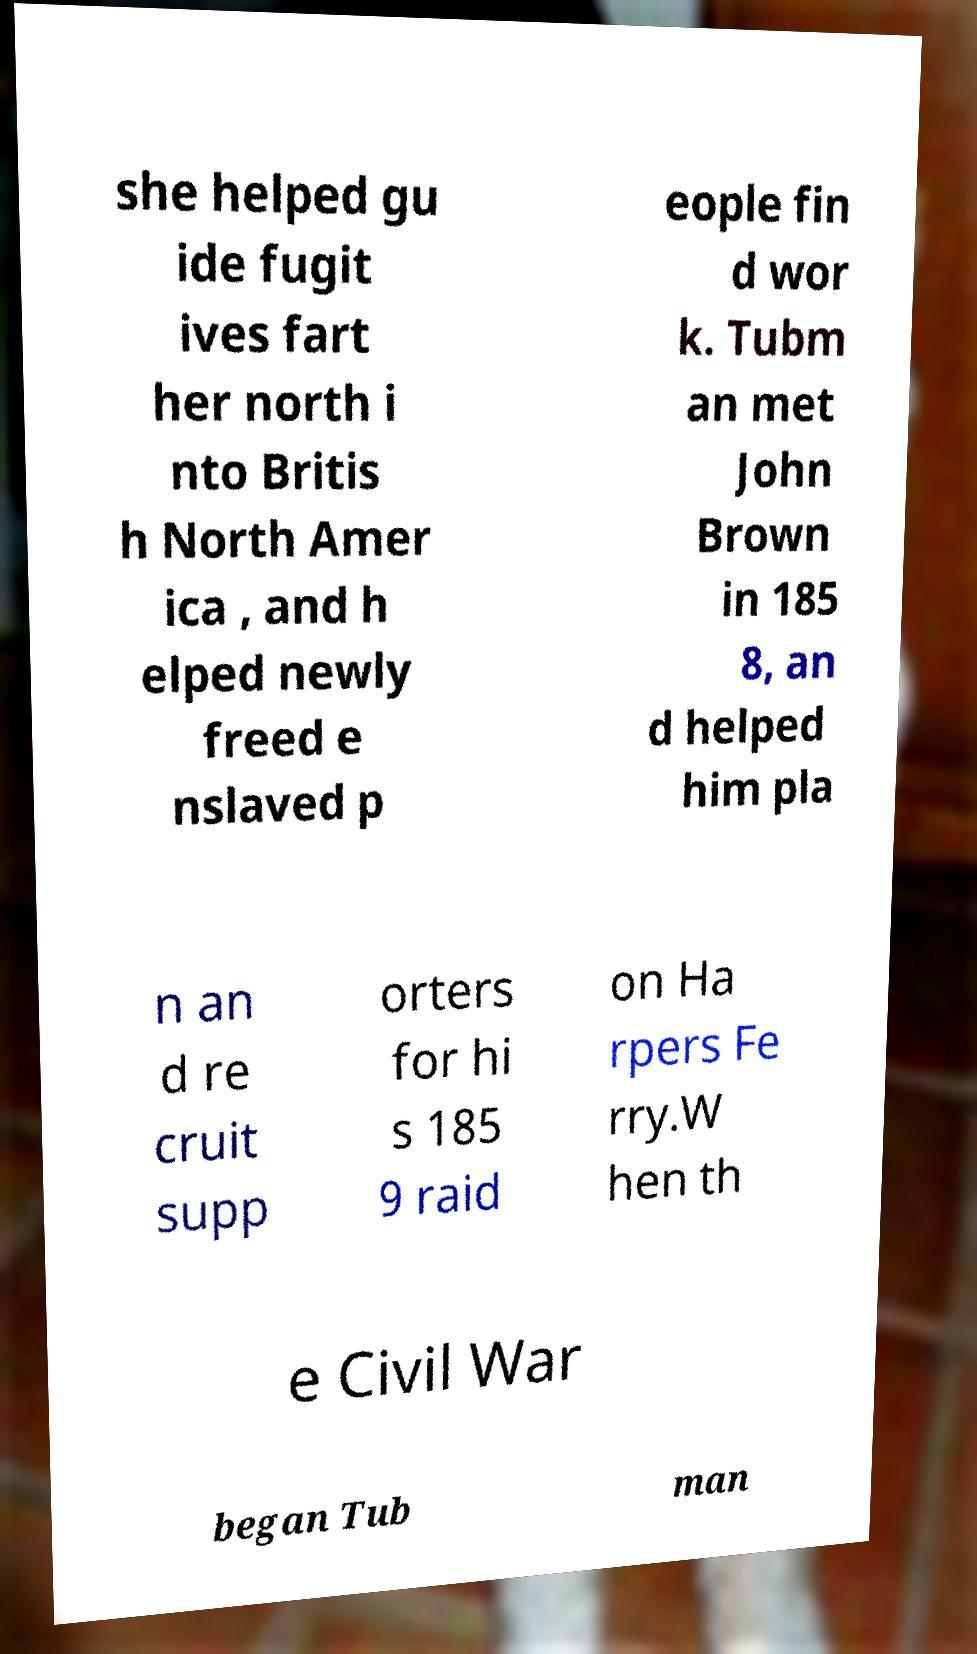Please identify and transcribe the text found in this image. she helped gu ide fugit ives fart her north i nto Britis h North Amer ica , and h elped newly freed e nslaved p eople fin d wor k. Tubm an met John Brown in 185 8, an d helped him pla n an d re cruit supp orters for hi s 185 9 raid on Ha rpers Fe rry.W hen th e Civil War began Tub man 